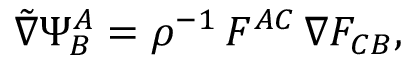Convert formula to latex. <formula><loc_0><loc_0><loc_500><loc_500>{ \tilde { \nabla } } \Psi _ { B } ^ { A } = \rho ^ { - 1 } \, F ^ { A C } \, \nabla F _ { C B } ,</formula> 